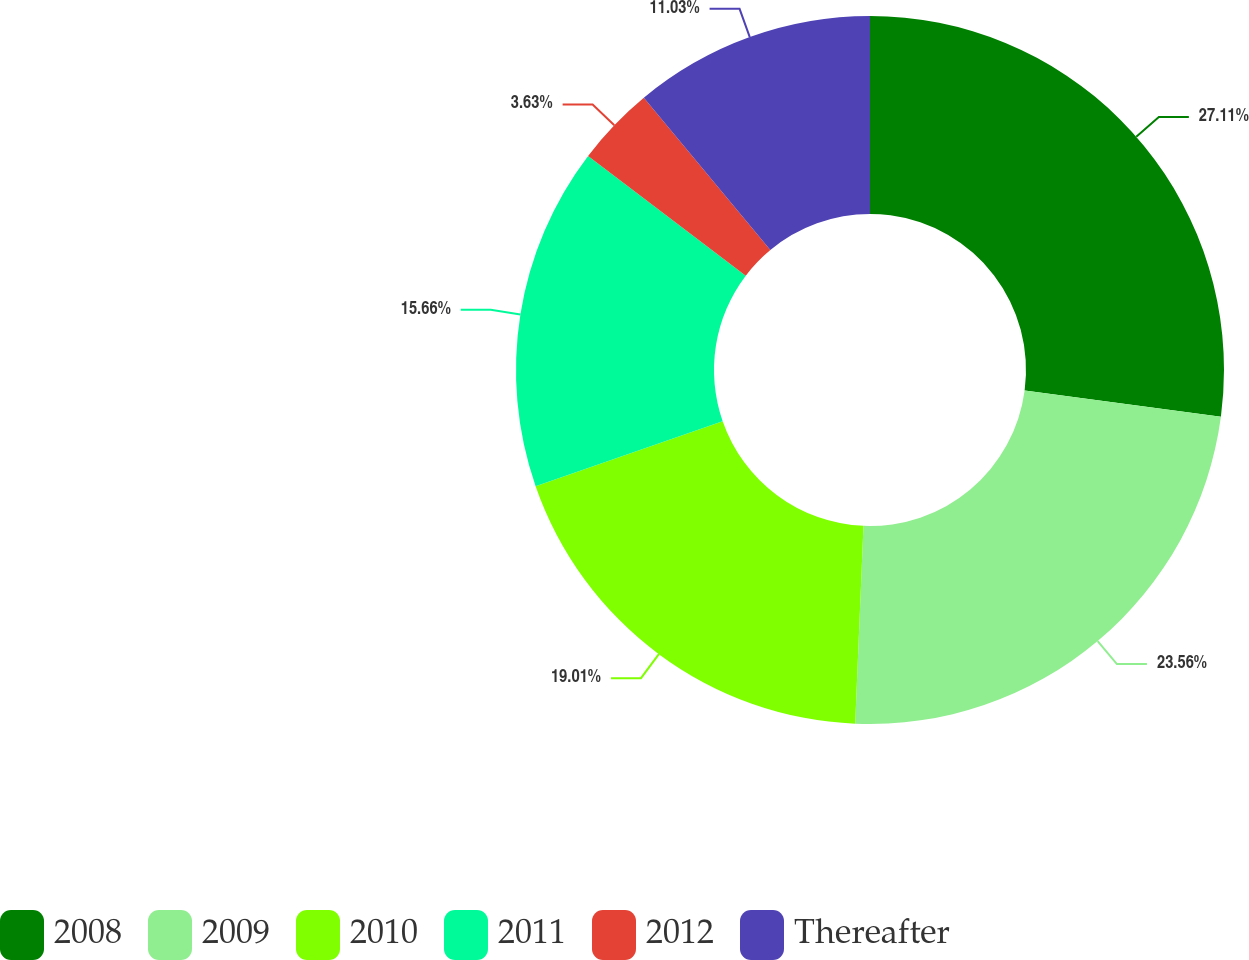Convert chart. <chart><loc_0><loc_0><loc_500><loc_500><pie_chart><fcel>2008<fcel>2009<fcel>2010<fcel>2011<fcel>2012<fcel>Thereafter<nl><fcel>27.1%<fcel>23.56%<fcel>19.01%<fcel>15.66%<fcel>3.63%<fcel>11.03%<nl></chart> 